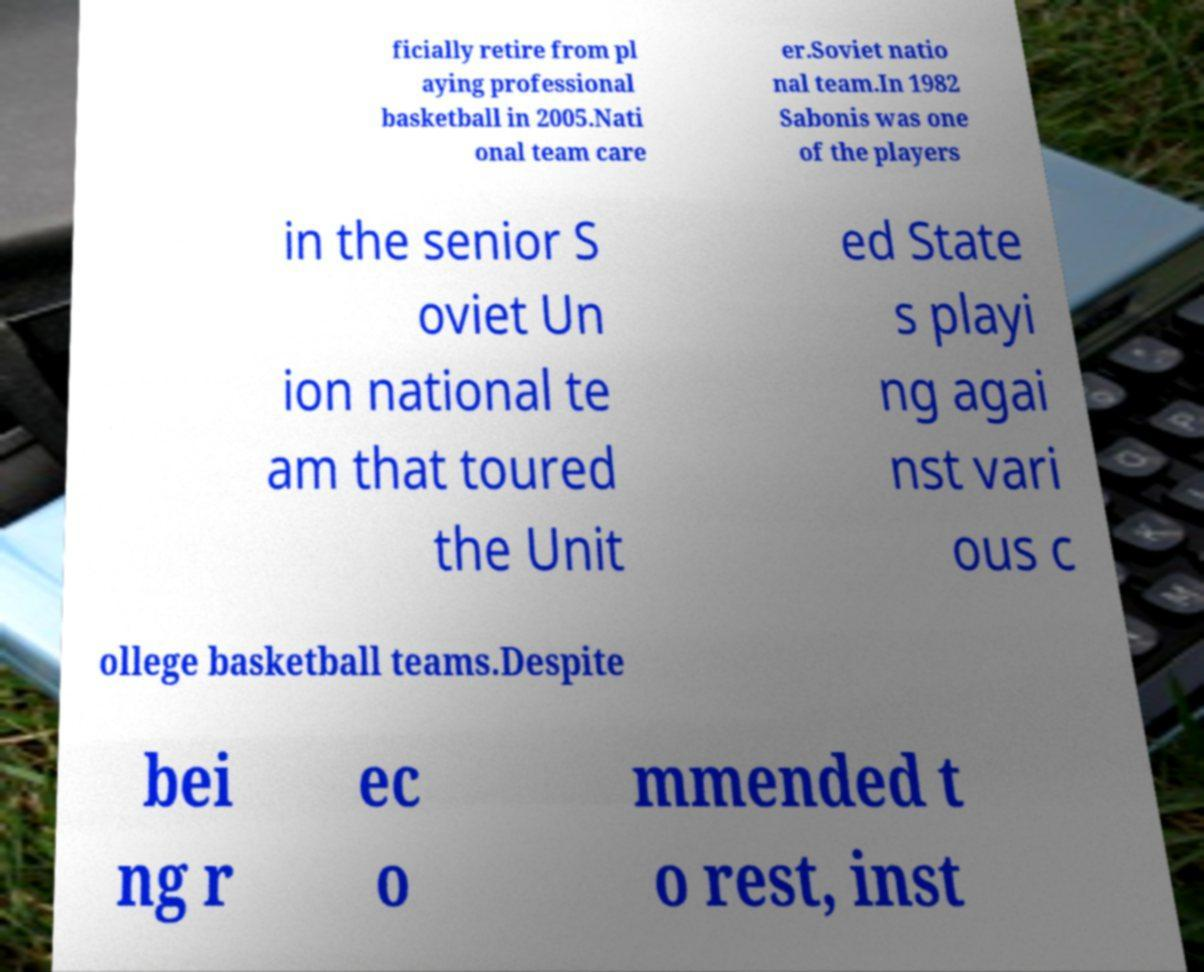Can you read and provide the text displayed in the image?This photo seems to have some interesting text. Can you extract and type it out for me? ficially retire from pl aying professional basketball in 2005.Nati onal team care er.Soviet natio nal team.In 1982 Sabonis was one of the players in the senior S oviet Un ion national te am that toured the Unit ed State s playi ng agai nst vari ous c ollege basketball teams.Despite bei ng r ec o mmended t o rest, inst 